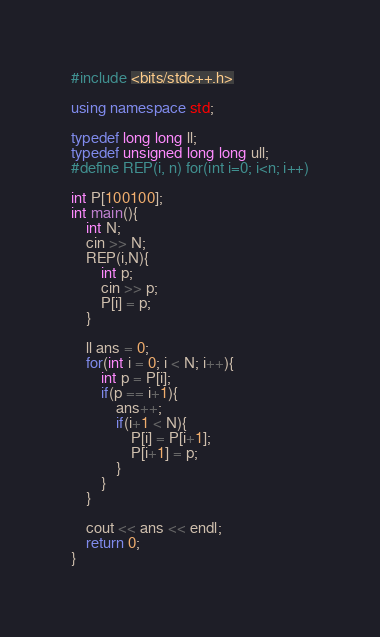<code> <loc_0><loc_0><loc_500><loc_500><_C++_>#include <bits/stdc++.h>

using namespace std;

typedef long long ll;
typedef unsigned long long ull;
#define REP(i, n) for(int i=0; i<n; i++)

int P[100100];
int main(){
    int N;
    cin >> N;
    REP(i,N){
        int p;
        cin >> p;
        P[i] = p;
    }

    ll ans = 0;
    for(int i = 0; i < N; i++){
        int p = P[i];
        if(p == i+1){
            ans++;
            if(i+1 < N){
                P[i] = P[i+1];
                P[i+1] = p;
            }
        }
    }

    cout << ans << endl;
    return 0;
}

</code> 